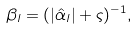Convert formula to latex. <formula><loc_0><loc_0><loc_500><loc_500>\beta _ { l } = ( | \hat { \alpha } _ { l } | + \varsigma ) ^ { - 1 } ,</formula> 